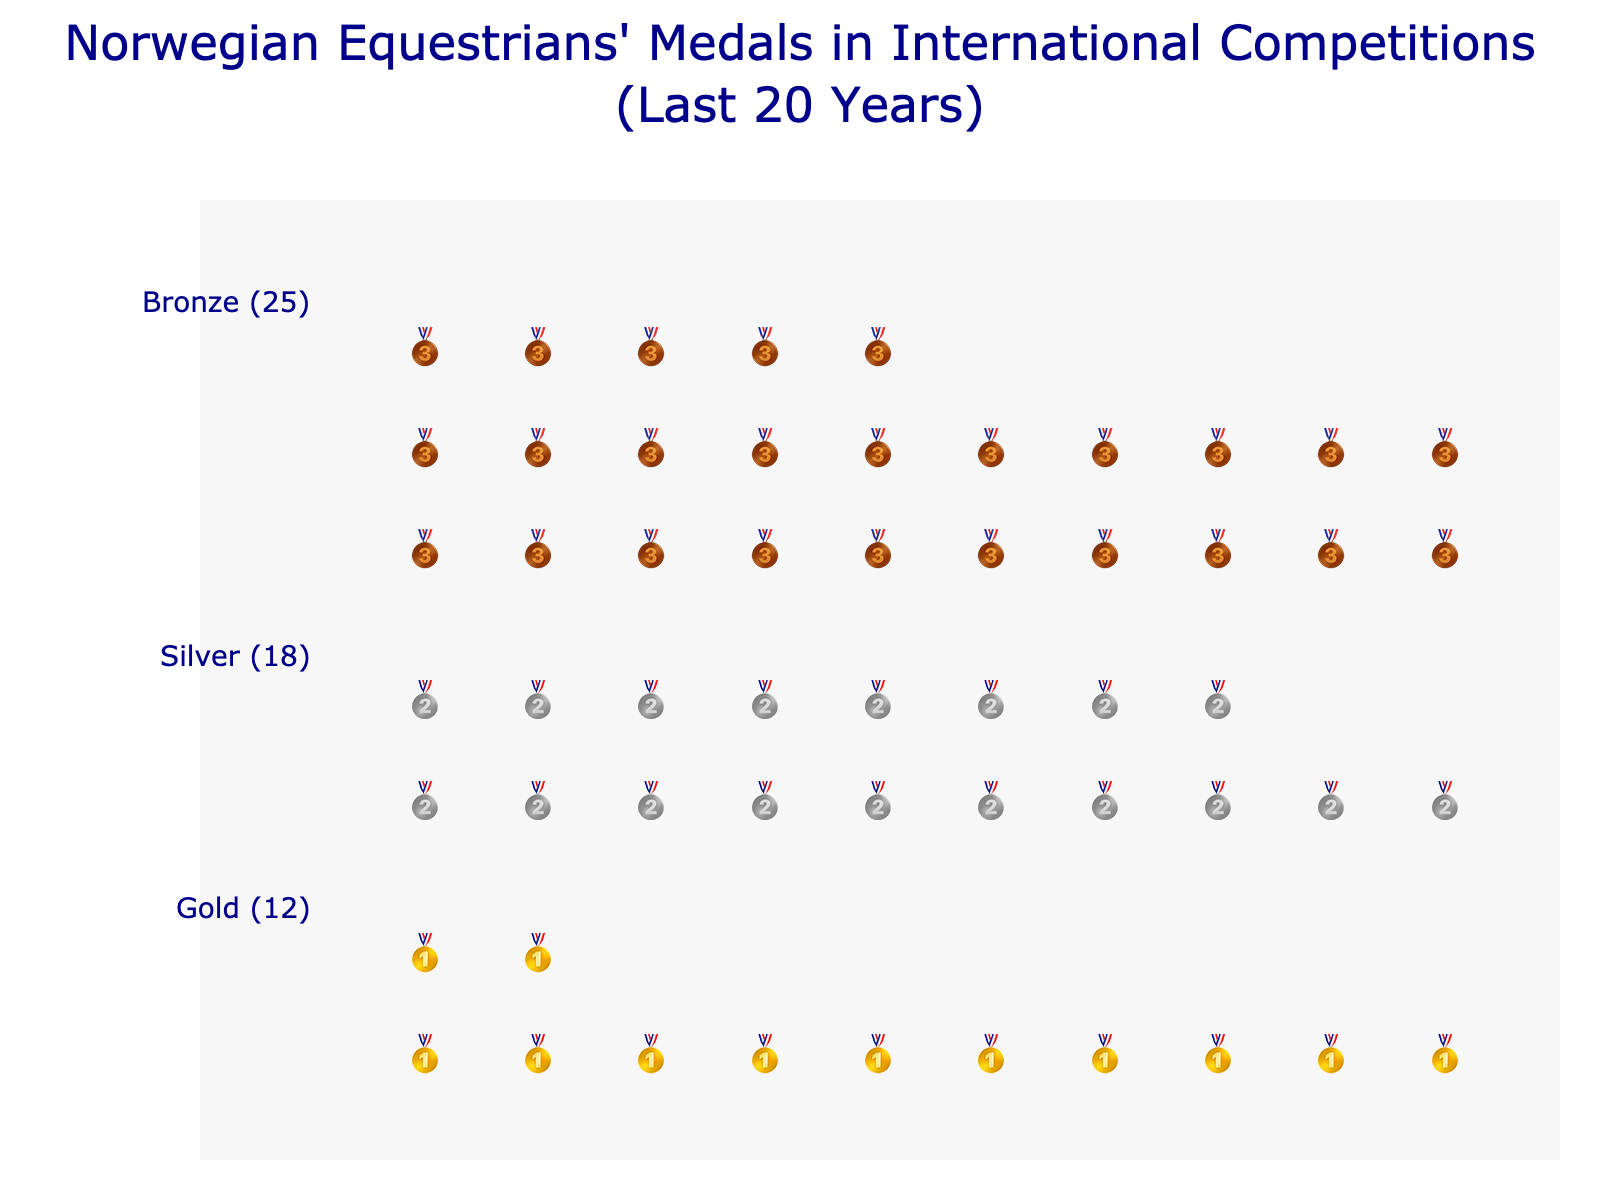Which medal type did Norwegian equestrians win the most in the past 20 years? By looking at the plot, the bronze medal 🥉 icons are the most numerous, indicating that it is the most won medal type.
Answer: Bronze How many total medals did Norwegian equestrians win in the past 20 years? The plot has a total medals annotation at the bottom, specifying the total count.
Answer: 55 How many gold medals were won? The figure includes an annotation next to the gold medals, specifying their count.
Answer: 12 How many silver medals did Norwegian equestrians win compared to bronze medals? The figure annotations show that there are 18 silver medals and 25 bronze medals. So, the difference is 25 - 18.
Answer: 7 What is the combined total of gold and silver medals won? The gold medals are 12 and the silver medals are 18. Adding these together, 12 + 18.
Answer: 30 Which type of medal forms the smallest portion of the total medals won, and by how much? The gold medal count is the lowest at 12. The difference between gold and silver is 18 - 12 and the difference between gold and bronze is 25 - 12.
Answer: Gold by 6 medals compared to silver and 13 medals compared to bronze How can you tell which medal type has the second-highest frequency? The annotation next to each medal type and the relative number of icons indicate that silver medals (18) are the second most frequent.
Answer: Silver How many full rows of medal icons does the bronze medal have, and how many are in the last partial row? The bronze medals form 2 full rows (with 10 icons each) and a partial row of 5 icons, as per the visualization in the plot.
Answer: 2 full rows, 5 in the last row How does the number of silver medals compare to the total number of medals? The total medals are 55, and the silver medals are 18. The ratio of silver to total is 18/55.
Answer: About 33% How is the label for each medal type formatted in the plot? Each medal type has a label next to its icons with the name and count in parenthesis, in a dark blue font for easy readability.
Answer: Medal type (count) in dark blue font 